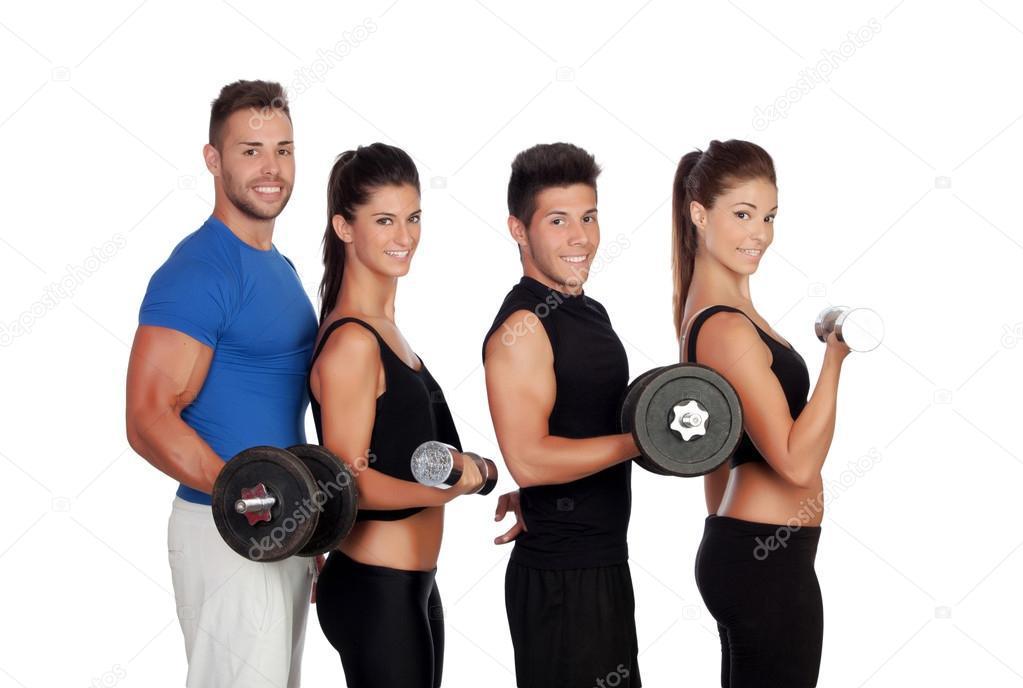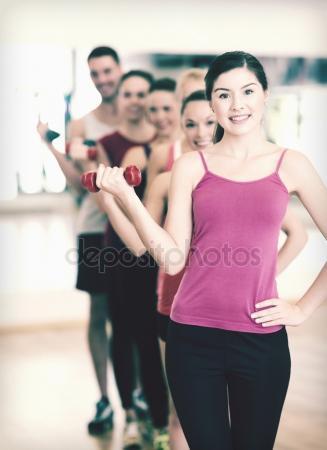The first image is the image on the left, the second image is the image on the right. For the images displayed, is the sentence "The right image includes two people sitting facing forward, each with one dumbbell in a lowered hand and one in a raised hand." factually correct? Answer yes or no. No. The first image is the image on the left, the second image is the image on the right. Evaluate the accuracy of this statement regarding the images: "The left and right image contains a total of five people lifting weights.". Is it true? Answer yes or no. No. 